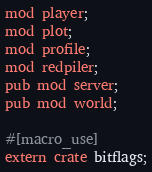<code> <loc_0><loc_0><loc_500><loc_500><_Rust_>mod player;
mod plot;
mod profile;
mod redpiler;
pub mod server;
pub mod world;

#[macro_use]
extern crate bitflags;
</code> 